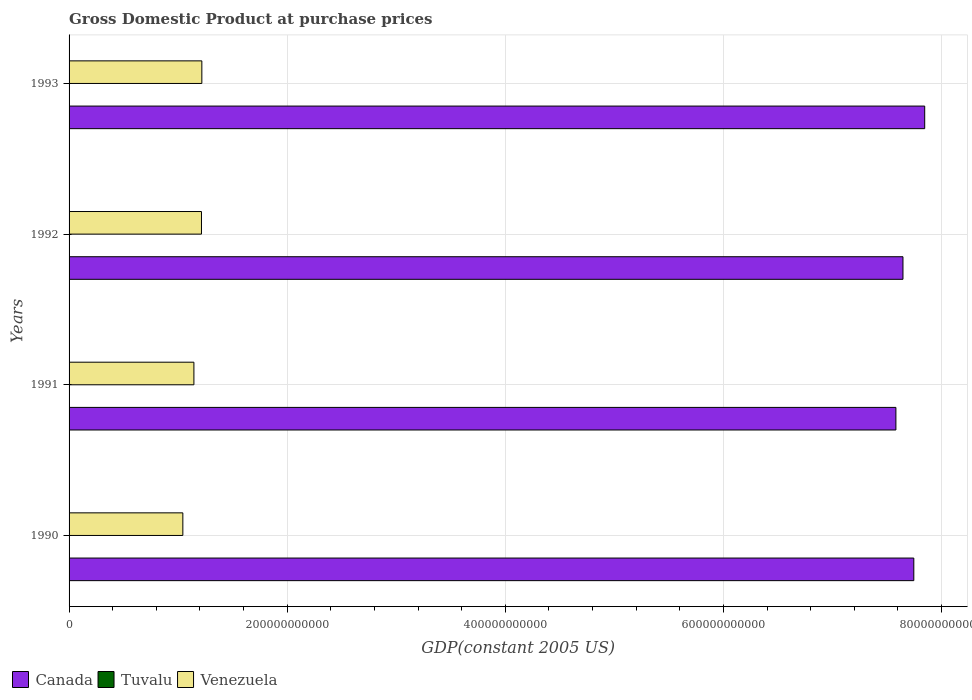How many groups of bars are there?
Your answer should be compact. 4. How many bars are there on the 2nd tick from the top?
Keep it short and to the point. 3. How many bars are there on the 4th tick from the bottom?
Make the answer very short. 3. What is the label of the 3rd group of bars from the top?
Keep it short and to the point. 1991. What is the GDP at purchase prices in Venezuela in 1993?
Provide a succinct answer. 1.22e+11. Across all years, what is the maximum GDP at purchase prices in Tuvalu?
Offer a very short reply. 1.78e+07. Across all years, what is the minimum GDP at purchase prices in Canada?
Offer a terse response. 7.58e+11. In which year was the GDP at purchase prices in Venezuela maximum?
Give a very brief answer. 1993. In which year was the GDP at purchase prices in Tuvalu minimum?
Offer a very short reply. 1990. What is the total GDP at purchase prices in Canada in the graph?
Offer a very short reply. 3.08e+12. What is the difference between the GDP at purchase prices in Venezuela in 1992 and that in 1993?
Provide a short and direct response. -3.34e+08. What is the difference between the GDP at purchase prices in Canada in 1993 and the GDP at purchase prices in Venezuela in 1991?
Provide a succinct answer. 6.70e+11. What is the average GDP at purchase prices in Canada per year?
Offer a terse response. 7.70e+11. In the year 1990, what is the difference between the GDP at purchase prices in Tuvalu and GDP at purchase prices in Venezuela?
Your answer should be compact. -1.04e+11. In how many years, is the GDP at purchase prices in Canada greater than 440000000000 US$?
Ensure brevity in your answer.  4. What is the ratio of the GDP at purchase prices in Canada in 1992 to that in 1993?
Ensure brevity in your answer.  0.97. Is the GDP at purchase prices in Tuvalu in 1991 less than that in 1992?
Keep it short and to the point. Yes. What is the difference between the highest and the second highest GDP at purchase prices in Canada?
Your answer should be compact. 9.99e+09. What is the difference between the highest and the lowest GDP at purchase prices in Canada?
Ensure brevity in your answer.  2.64e+1. Is the sum of the GDP at purchase prices in Tuvalu in 1991 and 1993 greater than the maximum GDP at purchase prices in Venezuela across all years?
Provide a succinct answer. No. What does the 1st bar from the top in 1993 represents?
Provide a short and direct response. Venezuela. How many bars are there?
Provide a short and direct response. 12. Are all the bars in the graph horizontal?
Provide a short and direct response. Yes. What is the difference between two consecutive major ticks on the X-axis?
Offer a very short reply. 2.00e+11. What is the title of the graph?
Provide a short and direct response. Gross Domestic Product at purchase prices. Does "Panama" appear as one of the legend labels in the graph?
Ensure brevity in your answer.  No. What is the label or title of the X-axis?
Offer a terse response. GDP(constant 2005 US). What is the GDP(constant 2005 US) in Canada in 1990?
Your answer should be compact. 7.75e+11. What is the GDP(constant 2005 US) of Tuvalu in 1990?
Your answer should be compact. 1.60e+07. What is the GDP(constant 2005 US) in Venezuela in 1990?
Make the answer very short. 1.04e+11. What is the GDP(constant 2005 US) of Canada in 1991?
Your answer should be compact. 7.58e+11. What is the GDP(constant 2005 US) of Tuvalu in 1991?
Your response must be concise. 1.66e+07. What is the GDP(constant 2005 US) of Venezuela in 1991?
Your response must be concise. 1.14e+11. What is the GDP(constant 2005 US) of Canada in 1992?
Offer a very short reply. 7.65e+11. What is the GDP(constant 2005 US) of Tuvalu in 1992?
Keep it short and to the point. 1.71e+07. What is the GDP(constant 2005 US) of Venezuela in 1992?
Keep it short and to the point. 1.21e+11. What is the GDP(constant 2005 US) in Canada in 1993?
Provide a short and direct response. 7.85e+11. What is the GDP(constant 2005 US) in Tuvalu in 1993?
Offer a very short reply. 1.78e+07. What is the GDP(constant 2005 US) of Venezuela in 1993?
Offer a very short reply. 1.22e+11. Across all years, what is the maximum GDP(constant 2005 US) of Canada?
Your response must be concise. 7.85e+11. Across all years, what is the maximum GDP(constant 2005 US) in Tuvalu?
Ensure brevity in your answer.  1.78e+07. Across all years, what is the maximum GDP(constant 2005 US) in Venezuela?
Provide a short and direct response. 1.22e+11. Across all years, what is the minimum GDP(constant 2005 US) in Canada?
Offer a terse response. 7.58e+11. Across all years, what is the minimum GDP(constant 2005 US) of Tuvalu?
Your response must be concise. 1.60e+07. Across all years, what is the minimum GDP(constant 2005 US) in Venezuela?
Provide a succinct answer. 1.04e+11. What is the total GDP(constant 2005 US) of Canada in the graph?
Give a very brief answer. 3.08e+12. What is the total GDP(constant 2005 US) in Tuvalu in the graph?
Provide a short and direct response. 6.75e+07. What is the total GDP(constant 2005 US) of Venezuela in the graph?
Keep it short and to the point. 4.62e+11. What is the difference between the GDP(constant 2005 US) in Canada in 1990 and that in 1991?
Provide a succinct answer. 1.64e+1. What is the difference between the GDP(constant 2005 US) in Tuvalu in 1990 and that in 1991?
Your answer should be very brief. -5.79e+05. What is the difference between the GDP(constant 2005 US) in Venezuela in 1990 and that in 1991?
Offer a very short reply. -1.01e+1. What is the difference between the GDP(constant 2005 US) of Canada in 1990 and that in 1992?
Make the answer very short. 9.95e+09. What is the difference between the GDP(constant 2005 US) in Tuvalu in 1990 and that in 1992?
Your answer should be compact. -1.04e+06. What is the difference between the GDP(constant 2005 US) in Venezuela in 1990 and that in 1992?
Offer a terse response. -1.71e+1. What is the difference between the GDP(constant 2005 US) of Canada in 1990 and that in 1993?
Keep it short and to the point. -9.99e+09. What is the difference between the GDP(constant 2005 US) of Tuvalu in 1990 and that in 1993?
Offer a terse response. -1.75e+06. What is the difference between the GDP(constant 2005 US) in Venezuela in 1990 and that in 1993?
Your response must be concise. -1.74e+1. What is the difference between the GDP(constant 2005 US) in Canada in 1991 and that in 1992?
Keep it short and to the point. -6.48e+09. What is the difference between the GDP(constant 2005 US) in Tuvalu in 1991 and that in 1992?
Make the answer very short. -4.64e+05. What is the difference between the GDP(constant 2005 US) in Venezuela in 1991 and that in 1992?
Offer a very short reply. -6.94e+09. What is the difference between the GDP(constant 2005 US) of Canada in 1991 and that in 1993?
Offer a very short reply. -2.64e+1. What is the difference between the GDP(constant 2005 US) of Tuvalu in 1991 and that in 1993?
Ensure brevity in your answer.  -1.17e+06. What is the difference between the GDP(constant 2005 US) in Venezuela in 1991 and that in 1993?
Provide a short and direct response. -7.27e+09. What is the difference between the GDP(constant 2005 US) of Canada in 1992 and that in 1993?
Offer a very short reply. -1.99e+1. What is the difference between the GDP(constant 2005 US) of Tuvalu in 1992 and that in 1993?
Offer a terse response. -7.02e+05. What is the difference between the GDP(constant 2005 US) in Venezuela in 1992 and that in 1993?
Offer a very short reply. -3.34e+08. What is the difference between the GDP(constant 2005 US) in Canada in 1990 and the GDP(constant 2005 US) in Tuvalu in 1991?
Your answer should be compact. 7.75e+11. What is the difference between the GDP(constant 2005 US) in Canada in 1990 and the GDP(constant 2005 US) in Venezuela in 1991?
Provide a short and direct response. 6.60e+11. What is the difference between the GDP(constant 2005 US) in Tuvalu in 1990 and the GDP(constant 2005 US) in Venezuela in 1991?
Your response must be concise. -1.14e+11. What is the difference between the GDP(constant 2005 US) in Canada in 1990 and the GDP(constant 2005 US) in Tuvalu in 1992?
Your response must be concise. 7.75e+11. What is the difference between the GDP(constant 2005 US) in Canada in 1990 and the GDP(constant 2005 US) in Venezuela in 1992?
Ensure brevity in your answer.  6.53e+11. What is the difference between the GDP(constant 2005 US) of Tuvalu in 1990 and the GDP(constant 2005 US) of Venezuela in 1992?
Offer a terse response. -1.21e+11. What is the difference between the GDP(constant 2005 US) of Canada in 1990 and the GDP(constant 2005 US) of Tuvalu in 1993?
Your response must be concise. 7.75e+11. What is the difference between the GDP(constant 2005 US) of Canada in 1990 and the GDP(constant 2005 US) of Venezuela in 1993?
Provide a succinct answer. 6.53e+11. What is the difference between the GDP(constant 2005 US) of Tuvalu in 1990 and the GDP(constant 2005 US) of Venezuela in 1993?
Offer a very short reply. -1.22e+11. What is the difference between the GDP(constant 2005 US) in Canada in 1991 and the GDP(constant 2005 US) in Tuvalu in 1992?
Your answer should be very brief. 7.58e+11. What is the difference between the GDP(constant 2005 US) of Canada in 1991 and the GDP(constant 2005 US) of Venezuela in 1992?
Provide a short and direct response. 6.37e+11. What is the difference between the GDP(constant 2005 US) in Tuvalu in 1991 and the GDP(constant 2005 US) in Venezuela in 1992?
Keep it short and to the point. -1.21e+11. What is the difference between the GDP(constant 2005 US) in Canada in 1991 and the GDP(constant 2005 US) in Tuvalu in 1993?
Your response must be concise. 7.58e+11. What is the difference between the GDP(constant 2005 US) of Canada in 1991 and the GDP(constant 2005 US) of Venezuela in 1993?
Give a very brief answer. 6.36e+11. What is the difference between the GDP(constant 2005 US) in Tuvalu in 1991 and the GDP(constant 2005 US) in Venezuela in 1993?
Keep it short and to the point. -1.22e+11. What is the difference between the GDP(constant 2005 US) in Canada in 1992 and the GDP(constant 2005 US) in Tuvalu in 1993?
Your answer should be compact. 7.65e+11. What is the difference between the GDP(constant 2005 US) in Canada in 1992 and the GDP(constant 2005 US) in Venezuela in 1993?
Ensure brevity in your answer.  6.43e+11. What is the difference between the GDP(constant 2005 US) of Tuvalu in 1992 and the GDP(constant 2005 US) of Venezuela in 1993?
Provide a succinct answer. -1.22e+11. What is the average GDP(constant 2005 US) in Canada per year?
Make the answer very short. 7.70e+11. What is the average GDP(constant 2005 US) of Tuvalu per year?
Your answer should be very brief. 1.69e+07. What is the average GDP(constant 2005 US) of Venezuela per year?
Ensure brevity in your answer.  1.15e+11. In the year 1990, what is the difference between the GDP(constant 2005 US) of Canada and GDP(constant 2005 US) of Tuvalu?
Offer a very short reply. 7.75e+11. In the year 1990, what is the difference between the GDP(constant 2005 US) in Canada and GDP(constant 2005 US) in Venezuela?
Provide a short and direct response. 6.70e+11. In the year 1990, what is the difference between the GDP(constant 2005 US) of Tuvalu and GDP(constant 2005 US) of Venezuela?
Make the answer very short. -1.04e+11. In the year 1991, what is the difference between the GDP(constant 2005 US) of Canada and GDP(constant 2005 US) of Tuvalu?
Make the answer very short. 7.58e+11. In the year 1991, what is the difference between the GDP(constant 2005 US) in Canada and GDP(constant 2005 US) in Venezuela?
Provide a short and direct response. 6.44e+11. In the year 1991, what is the difference between the GDP(constant 2005 US) of Tuvalu and GDP(constant 2005 US) of Venezuela?
Give a very brief answer. -1.14e+11. In the year 1992, what is the difference between the GDP(constant 2005 US) of Canada and GDP(constant 2005 US) of Tuvalu?
Make the answer very short. 7.65e+11. In the year 1992, what is the difference between the GDP(constant 2005 US) of Canada and GDP(constant 2005 US) of Venezuela?
Offer a very short reply. 6.43e+11. In the year 1992, what is the difference between the GDP(constant 2005 US) of Tuvalu and GDP(constant 2005 US) of Venezuela?
Keep it short and to the point. -1.21e+11. In the year 1993, what is the difference between the GDP(constant 2005 US) of Canada and GDP(constant 2005 US) of Tuvalu?
Your response must be concise. 7.85e+11. In the year 1993, what is the difference between the GDP(constant 2005 US) in Canada and GDP(constant 2005 US) in Venezuela?
Your answer should be very brief. 6.63e+11. In the year 1993, what is the difference between the GDP(constant 2005 US) in Tuvalu and GDP(constant 2005 US) in Venezuela?
Provide a succinct answer. -1.22e+11. What is the ratio of the GDP(constant 2005 US) of Canada in 1990 to that in 1991?
Provide a succinct answer. 1.02. What is the ratio of the GDP(constant 2005 US) in Tuvalu in 1990 to that in 1991?
Your answer should be compact. 0.97. What is the ratio of the GDP(constant 2005 US) in Venezuela in 1990 to that in 1991?
Give a very brief answer. 0.91. What is the ratio of the GDP(constant 2005 US) in Canada in 1990 to that in 1992?
Offer a terse response. 1.01. What is the ratio of the GDP(constant 2005 US) of Tuvalu in 1990 to that in 1992?
Offer a very short reply. 0.94. What is the ratio of the GDP(constant 2005 US) in Venezuela in 1990 to that in 1992?
Your response must be concise. 0.86. What is the ratio of the GDP(constant 2005 US) of Canada in 1990 to that in 1993?
Your answer should be very brief. 0.99. What is the ratio of the GDP(constant 2005 US) of Tuvalu in 1990 to that in 1993?
Offer a very short reply. 0.9. What is the ratio of the GDP(constant 2005 US) of Venezuela in 1990 to that in 1993?
Provide a succinct answer. 0.86. What is the ratio of the GDP(constant 2005 US) in Canada in 1991 to that in 1992?
Give a very brief answer. 0.99. What is the ratio of the GDP(constant 2005 US) of Tuvalu in 1991 to that in 1992?
Offer a very short reply. 0.97. What is the ratio of the GDP(constant 2005 US) of Venezuela in 1991 to that in 1992?
Your response must be concise. 0.94. What is the ratio of the GDP(constant 2005 US) of Canada in 1991 to that in 1993?
Provide a succinct answer. 0.97. What is the ratio of the GDP(constant 2005 US) in Tuvalu in 1991 to that in 1993?
Your answer should be very brief. 0.93. What is the ratio of the GDP(constant 2005 US) of Venezuela in 1991 to that in 1993?
Your response must be concise. 0.94. What is the ratio of the GDP(constant 2005 US) of Canada in 1992 to that in 1993?
Your answer should be very brief. 0.97. What is the ratio of the GDP(constant 2005 US) in Tuvalu in 1992 to that in 1993?
Make the answer very short. 0.96. What is the ratio of the GDP(constant 2005 US) in Venezuela in 1992 to that in 1993?
Make the answer very short. 1. What is the difference between the highest and the second highest GDP(constant 2005 US) in Canada?
Your answer should be very brief. 9.99e+09. What is the difference between the highest and the second highest GDP(constant 2005 US) of Tuvalu?
Provide a succinct answer. 7.02e+05. What is the difference between the highest and the second highest GDP(constant 2005 US) of Venezuela?
Provide a short and direct response. 3.34e+08. What is the difference between the highest and the lowest GDP(constant 2005 US) in Canada?
Provide a short and direct response. 2.64e+1. What is the difference between the highest and the lowest GDP(constant 2005 US) in Tuvalu?
Offer a very short reply. 1.75e+06. What is the difference between the highest and the lowest GDP(constant 2005 US) of Venezuela?
Provide a short and direct response. 1.74e+1. 